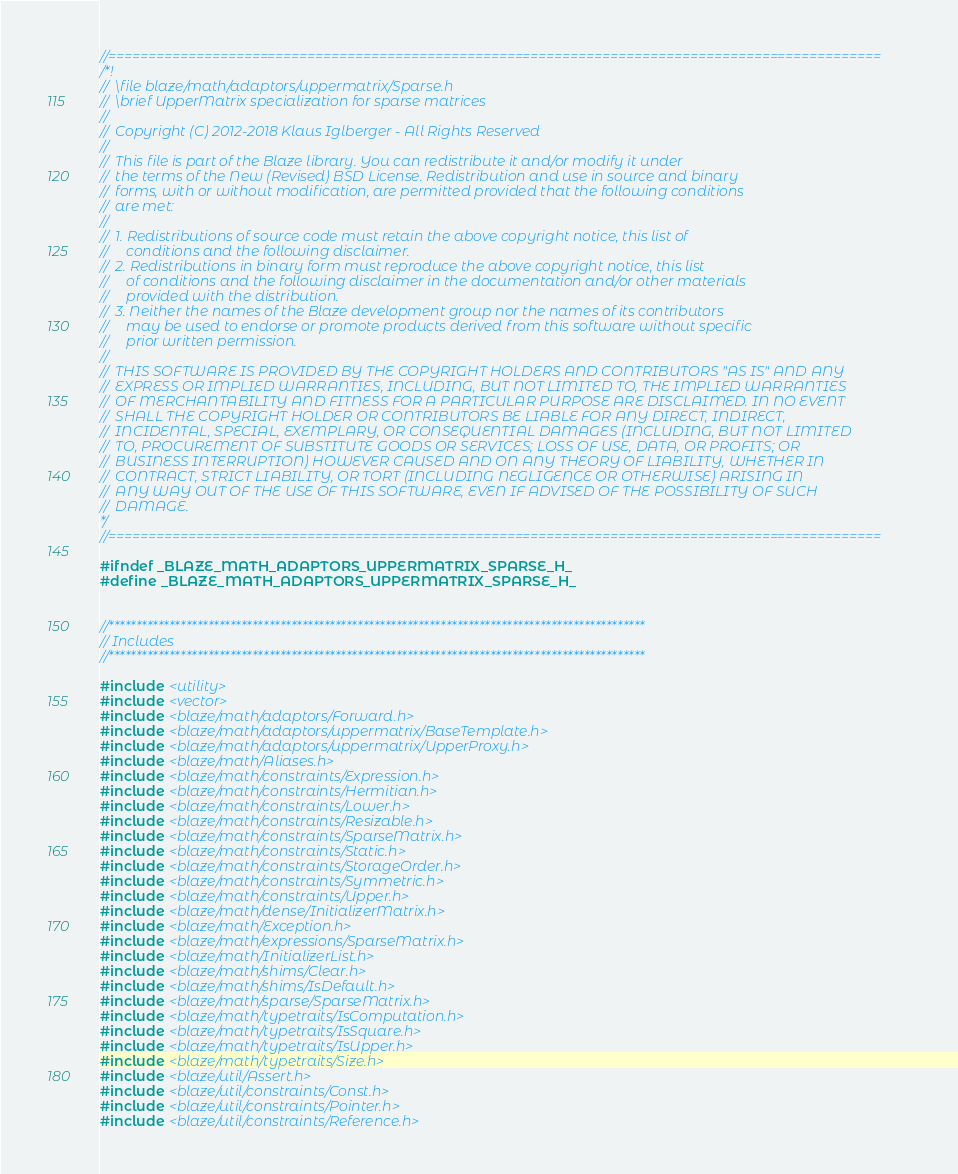<code> <loc_0><loc_0><loc_500><loc_500><_C_>//=================================================================================================
/*!
//  \file blaze/math/adaptors/uppermatrix/Sparse.h
//  \brief UpperMatrix specialization for sparse matrices
//
//  Copyright (C) 2012-2018 Klaus Iglberger - All Rights Reserved
//
//  This file is part of the Blaze library. You can redistribute it and/or modify it under
//  the terms of the New (Revised) BSD License. Redistribution and use in source and binary
//  forms, with or without modification, are permitted provided that the following conditions
//  are met:
//
//  1. Redistributions of source code must retain the above copyright notice, this list of
//     conditions and the following disclaimer.
//  2. Redistributions in binary form must reproduce the above copyright notice, this list
//     of conditions and the following disclaimer in the documentation and/or other materials
//     provided with the distribution.
//  3. Neither the names of the Blaze development group nor the names of its contributors
//     may be used to endorse or promote products derived from this software without specific
//     prior written permission.
//
//  THIS SOFTWARE IS PROVIDED BY THE COPYRIGHT HOLDERS AND CONTRIBUTORS "AS IS" AND ANY
//  EXPRESS OR IMPLIED WARRANTIES, INCLUDING, BUT NOT LIMITED TO, THE IMPLIED WARRANTIES
//  OF MERCHANTABILITY AND FITNESS FOR A PARTICULAR PURPOSE ARE DISCLAIMED. IN NO EVENT
//  SHALL THE COPYRIGHT HOLDER OR CONTRIBUTORS BE LIABLE FOR ANY DIRECT, INDIRECT,
//  INCIDENTAL, SPECIAL, EXEMPLARY, OR CONSEQUENTIAL DAMAGES (INCLUDING, BUT NOT LIMITED
//  TO, PROCUREMENT OF SUBSTITUTE GOODS OR SERVICES; LOSS OF USE, DATA, OR PROFITS; OR
//  BUSINESS INTERRUPTION) HOWEVER CAUSED AND ON ANY THEORY OF LIABILITY, WHETHER IN
//  CONTRACT, STRICT LIABILITY, OR TORT (INCLUDING NEGLIGENCE OR OTHERWISE) ARISING IN
//  ANY WAY OUT OF THE USE OF THIS SOFTWARE, EVEN IF ADVISED OF THE POSSIBILITY OF SUCH
//  DAMAGE.
*/
//=================================================================================================

#ifndef _BLAZE_MATH_ADAPTORS_UPPERMATRIX_SPARSE_H_
#define _BLAZE_MATH_ADAPTORS_UPPERMATRIX_SPARSE_H_


//*************************************************************************************************
// Includes
//*************************************************************************************************

#include <utility>
#include <vector>
#include <blaze/math/adaptors/Forward.h>
#include <blaze/math/adaptors/uppermatrix/BaseTemplate.h>
#include <blaze/math/adaptors/uppermatrix/UpperProxy.h>
#include <blaze/math/Aliases.h>
#include <blaze/math/constraints/Expression.h>
#include <blaze/math/constraints/Hermitian.h>
#include <blaze/math/constraints/Lower.h>
#include <blaze/math/constraints/Resizable.h>
#include <blaze/math/constraints/SparseMatrix.h>
#include <blaze/math/constraints/Static.h>
#include <blaze/math/constraints/StorageOrder.h>
#include <blaze/math/constraints/Symmetric.h>
#include <blaze/math/constraints/Upper.h>
#include <blaze/math/dense/InitializerMatrix.h>
#include <blaze/math/Exception.h>
#include <blaze/math/expressions/SparseMatrix.h>
#include <blaze/math/InitializerList.h>
#include <blaze/math/shims/Clear.h>
#include <blaze/math/shims/IsDefault.h>
#include <blaze/math/sparse/SparseMatrix.h>
#include <blaze/math/typetraits/IsComputation.h>
#include <blaze/math/typetraits/IsSquare.h>
#include <blaze/math/typetraits/IsUpper.h>
#include <blaze/math/typetraits/Size.h>
#include <blaze/util/Assert.h>
#include <blaze/util/constraints/Const.h>
#include <blaze/util/constraints/Pointer.h>
#include <blaze/util/constraints/Reference.h></code> 